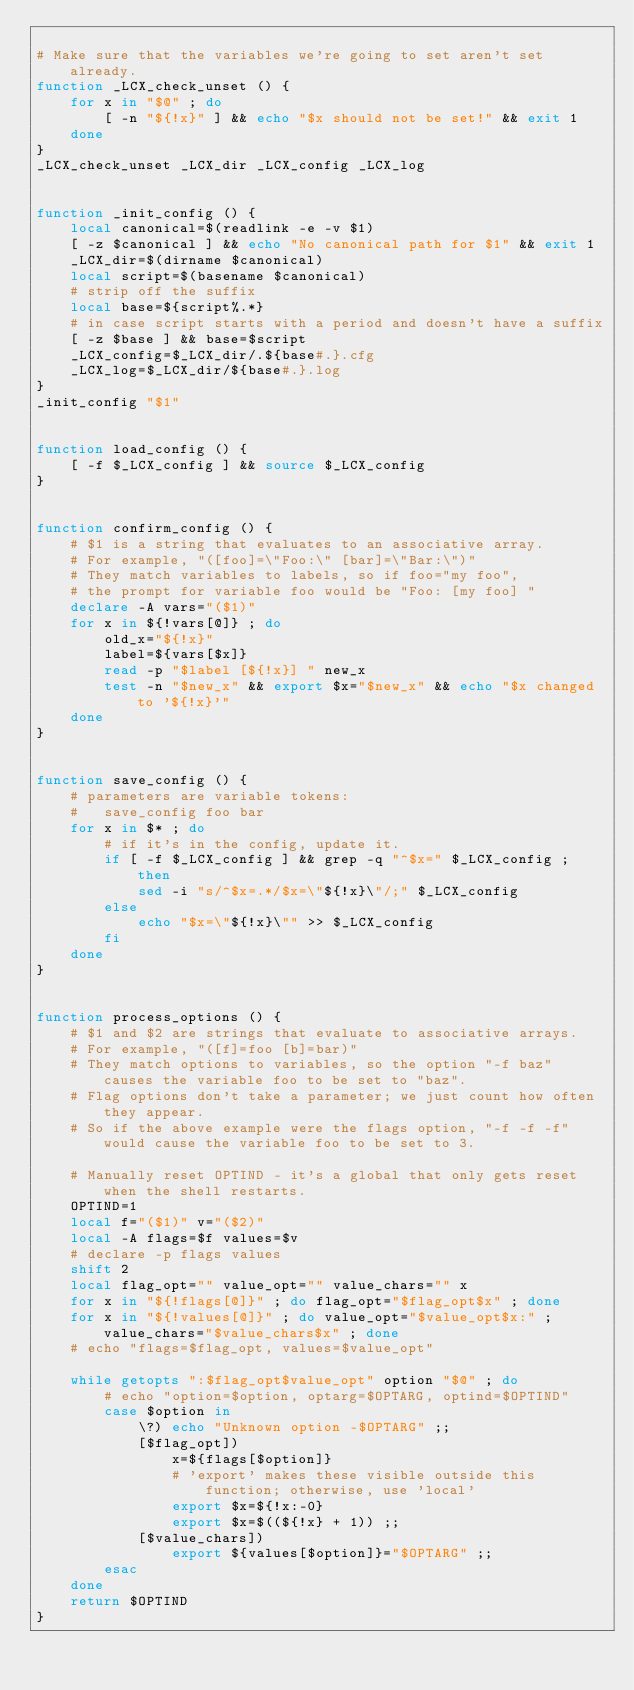<code> <loc_0><loc_0><loc_500><loc_500><_Bash_>
# Make sure that the variables we're going to set aren't set already.
function _LCX_check_unset () {
    for x in "$@" ; do
        [ -n "${!x}" ] && echo "$x should not be set!" && exit 1
    done
}
_LCX_check_unset _LCX_dir _LCX_config _LCX_log


function _init_config () {
    local canonical=$(readlink -e -v $1)
    [ -z $canonical ] && echo "No canonical path for $1" && exit 1
    _LCX_dir=$(dirname $canonical)
    local script=$(basename $canonical)
    # strip off the suffix
    local base=${script%.*}
    # in case script starts with a period and doesn't have a suffix
    [ -z $base ] && base=$script
    _LCX_config=$_LCX_dir/.${base#.}.cfg
    _LCX_log=$_LCX_dir/${base#.}.log
}
_init_config "$1"


function load_config () {
    [ -f $_LCX_config ] && source $_LCX_config
}


function confirm_config () {
    # $1 is a string that evaluates to an associative array.
    # For example, "([foo]=\"Foo:\" [bar]=\"Bar:\")"
    # They match variables to labels, so if foo="my foo",
    # the prompt for variable foo would be "Foo: [my foo] "
    declare -A vars="($1)"
    for x in ${!vars[@]} ; do
        old_x="${!x}"
        label=${vars[$x]}
        read -p "$label [${!x}] " new_x
        test -n "$new_x" && export $x="$new_x" && echo "$x changed to '${!x}'"
    done
}


function save_config () {
    # parameters are variable tokens:
    #   save_config foo bar
    for x in $* ; do
        # if it's in the config, update it.
        if [ -f $_LCX_config ] && grep -q "^$x=" $_LCX_config ; then
            sed -i "s/^$x=.*/$x=\"${!x}\"/;" $_LCX_config
        else
            echo "$x=\"${!x}\"" >> $_LCX_config
        fi
    done
}


function process_options () {
    # $1 and $2 are strings that evaluate to associative arrays.
    # For example, "([f]=foo [b]=bar)"
    # They match options to variables, so the option "-f baz" causes the variable foo to be set to "baz".
    # Flag options don't take a parameter; we just count how often they appear.
    # So if the above example were the flags option, "-f -f -f" would cause the variable foo to be set to 3.

    # Manually reset OPTIND - it's a global that only gets reset when the shell restarts.
    OPTIND=1
    local f="($1)" v="($2)"
    local -A flags=$f values=$v
    # declare -p flags values
    shift 2
    local flag_opt="" value_opt="" value_chars="" x
    for x in "${!flags[@]}" ; do flag_opt="$flag_opt$x" ; done
    for x in "${!values[@]}" ; do value_opt="$value_opt$x:" ; value_chars="$value_chars$x" ; done
    # echo "flags=$flag_opt, values=$value_opt"

    while getopts ":$flag_opt$value_opt" option "$@" ; do
        # echo "option=$option, optarg=$OPTARG, optind=$OPTIND"
        case $option in
            \?) echo "Unknown option -$OPTARG" ;;
            [$flag_opt])
                x=${flags[$option]}
                # 'export' makes these visible outside this function; otherwise, use 'local'
                export $x=${!x:-0}
                export $x=$((${!x} + 1)) ;;
            [$value_chars])
                export ${values[$option]}="$OPTARG" ;;
        esac
    done
    return $OPTIND
}

</code> 